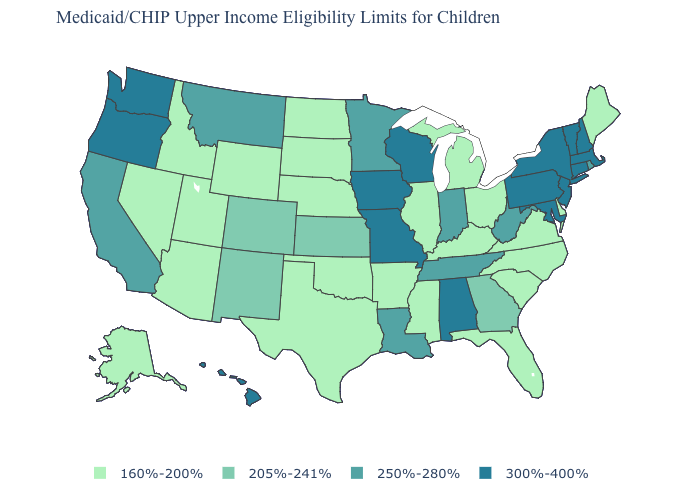Which states have the highest value in the USA?
Keep it brief. Alabama, Connecticut, Hawaii, Iowa, Maryland, Massachusetts, Missouri, New Hampshire, New Jersey, New York, Oregon, Pennsylvania, Vermont, Washington, Wisconsin. Among the states that border Nevada , does Idaho have the highest value?
Write a very short answer. No. What is the value of California?
Answer briefly. 250%-280%. What is the value of Georgia?
Give a very brief answer. 205%-241%. What is the value of Kentucky?
Answer briefly. 160%-200%. What is the lowest value in states that border Wisconsin?
Short answer required. 160%-200%. Does Rhode Island have the lowest value in the Northeast?
Short answer required. No. What is the value of Ohio?
Be succinct. 160%-200%. Among the states that border Iowa , which have the lowest value?
Be succinct. Illinois, Nebraska, South Dakota. Does New Hampshire have the same value as Pennsylvania?
Write a very short answer. Yes. What is the value of Wisconsin?
Concise answer only. 300%-400%. Does Montana have the lowest value in the USA?
Be succinct. No. Name the states that have a value in the range 300%-400%?
Be succinct. Alabama, Connecticut, Hawaii, Iowa, Maryland, Massachusetts, Missouri, New Hampshire, New Jersey, New York, Oregon, Pennsylvania, Vermont, Washington, Wisconsin. What is the highest value in the USA?
Give a very brief answer. 300%-400%. What is the lowest value in states that border Tennessee?
Concise answer only. 160%-200%. 